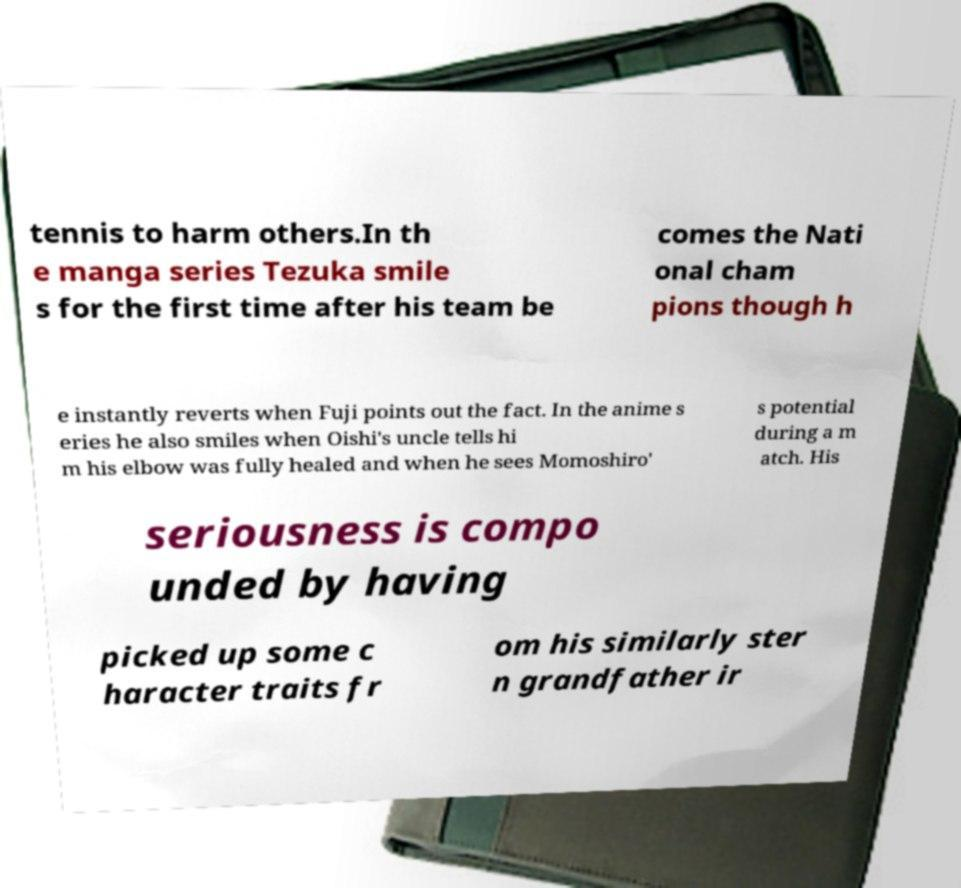I need the written content from this picture converted into text. Can you do that? tennis to harm others.In th e manga series Tezuka smile s for the first time after his team be comes the Nati onal cham pions though h e instantly reverts when Fuji points out the fact. In the anime s eries he also smiles when Oishi's uncle tells hi m his elbow was fully healed and when he sees Momoshiro' s potential during a m atch. His seriousness is compo unded by having picked up some c haracter traits fr om his similarly ster n grandfather ir 